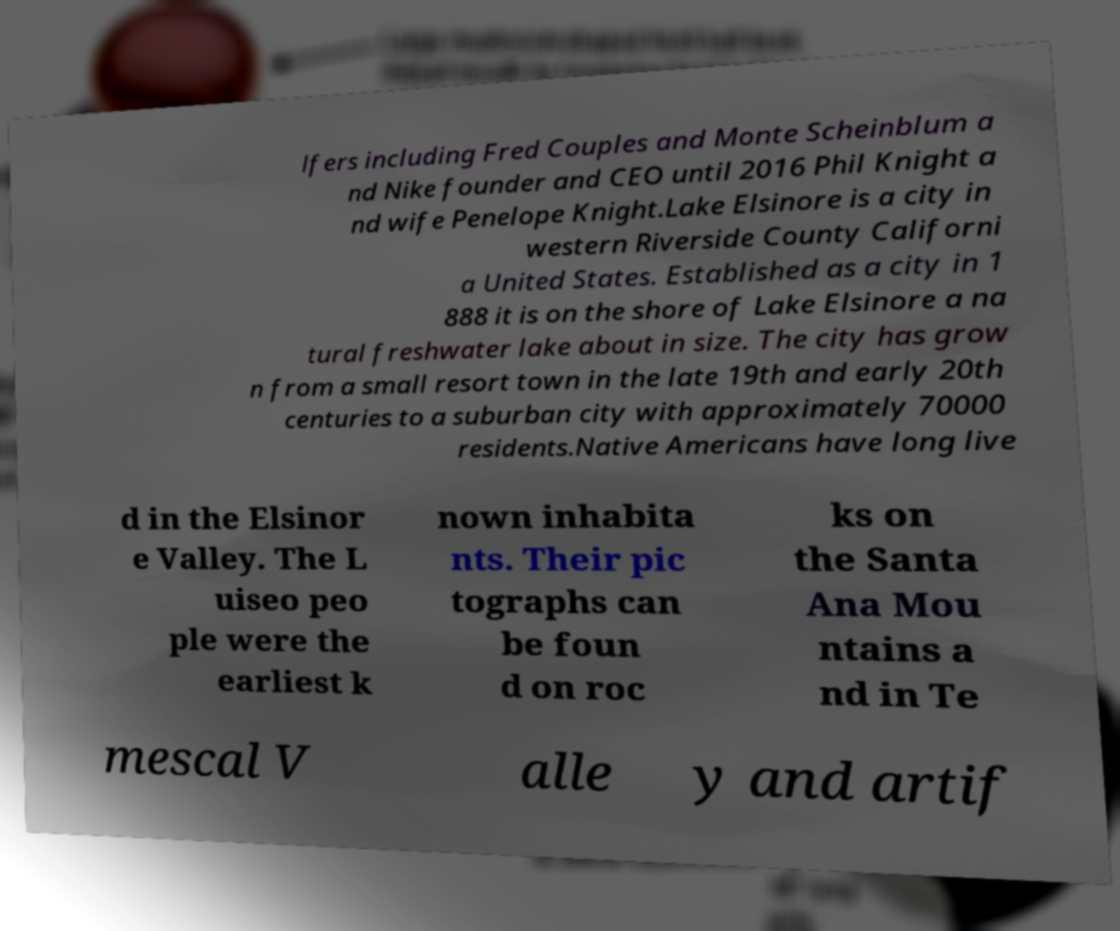What messages or text are displayed in this image? I need them in a readable, typed format. lfers including Fred Couples and Monte Scheinblum a nd Nike founder and CEO until 2016 Phil Knight a nd wife Penelope Knight.Lake Elsinore is a city in western Riverside County Californi a United States. Established as a city in 1 888 it is on the shore of Lake Elsinore a na tural freshwater lake about in size. The city has grow n from a small resort town in the late 19th and early 20th centuries to a suburban city with approximately 70000 residents.Native Americans have long live d in the Elsinor e Valley. The L uiseo peo ple were the earliest k nown inhabita nts. Their pic tographs can be foun d on roc ks on the Santa Ana Mou ntains a nd in Te mescal V alle y and artif 